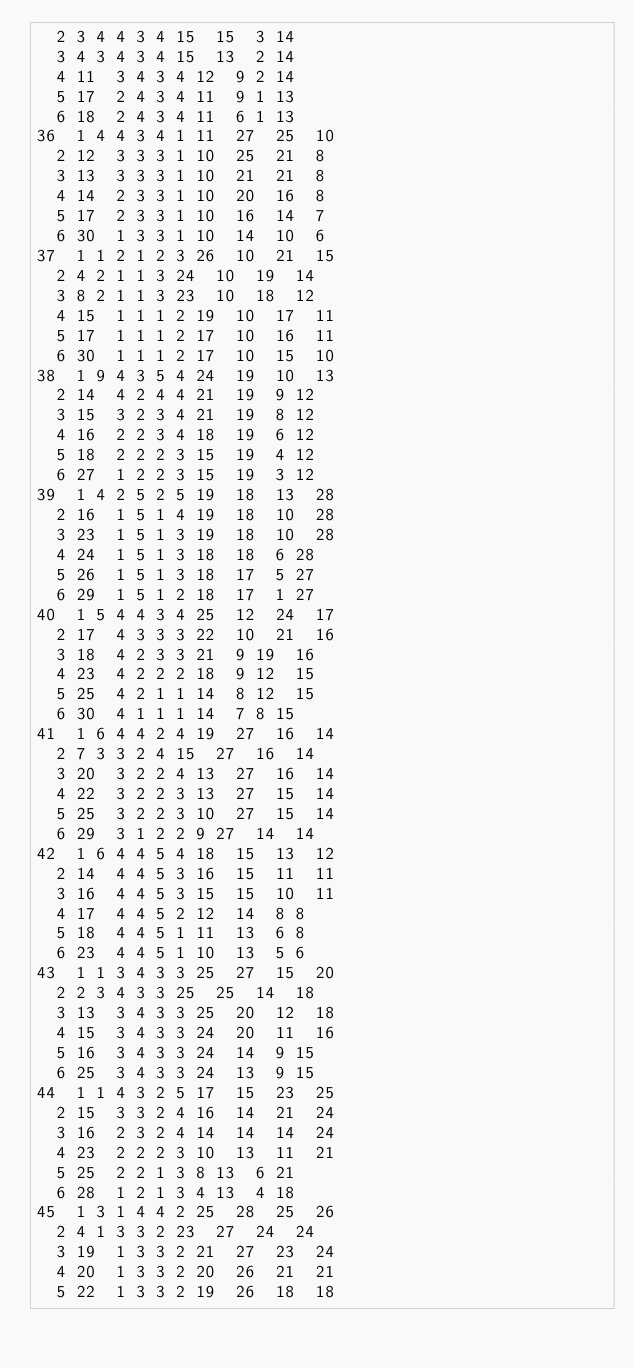Convert code to text. <code><loc_0><loc_0><loc_500><loc_500><_ObjectiveC_>	2	3	4	4	3	4	15	15	3	14	
	3	4	3	4	3	4	15	13	2	14	
	4	11	3	4	3	4	12	9	2	14	
	5	17	2	4	3	4	11	9	1	13	
	6	18	2	4	3	4	11	6	1	13	
36	1	4	4	3	4	1	11	27	25	10	
	2	12	3	3	3	1	10	25	21	8	
	3	13	3	3	3	1	10	21	21	8	
	4	14	2	3	3	1	10	20	16	8	
	5	17	2	3	3	1	10	16	14	7	
	6	30	1	3	3	1	10	14	10	6	
37	1	1	2	1	2	3	26	10	21	15	
	2	4	2	1	1	3	24	10	19	14	
	3	8	2	1	1	3	23	10	18	12	
	4	15	1	1	1	2	19	10	17	11	
	5	17	1	1	1	2	17	10	16	11	
	6	30	1	1	1	2	17	10	15	10	
38	1	9	4	3	5	4	24	19	10	13	
	2	14	4	2	4	4	21	19	9	12	
	3	15	3	2	3	4	21	19	8	12	
	4	16	2	2	3	4	18	19	6	12	
	5	18	2	2	2	3	15	19	4	12	
	6	27	1	2	2	3	15	19	3	12	
39	1	4	2	5	2	5	19	18	13	28	
	2	16	1	5	1	4	19	18	10	28	
	3	23	1	5	1	3	19	18	10	28	
	4	24	1	5	1	3	18	18	6	28	
	5	26	1	5	1	3	18	17	5	27	
	6	29	1	5	1	2	18	17	1	27	
40	1	5	4	4	3	4	25	12	24	17	
	2	17	4	3	3	3	22	10	21	16	
	3	18	4	2	3	3	21	9	19	16	
	4	23	4	2	2	2	18	9	12	15	
	5	25	4	2	1	1	14	8	12	15	
	6	30	4	1	1	1	14	7	8	15	
41	1	6	4	4	2	4	19	27	16	14	
	2	7	3	3	2	4	15	27	16	14	
	3	20	3	2	2	4	13	27	16	14	
	4	22	3	2	2	3	13	27	15	14	
	5	25	3	2	2	3	10	27	15	14	
	6	29	3	1	2	2	9	27	14	14	
42	1	6	4	4	5	4	18	15	13	12	
	2	14	4	4	5	3	16	15	11	11	
	3	16	4	4	5	3	15	15	10	11	
	4	17	4	4	5	2	12	14	8	8	
	5	18	4	4	5	1	11	13	6	8	
	6	23	4	4	5	1	10	13	5	6	
43	1	1	3	4	3	3	25	27	15	20	
	2	2	3	4	3	3	25	25	14	18	
	3	13	3	4	3	3	25	20	12	18	
	4	15	3	4	3	3	24	20	11	16	
	5	16	3	4	3	3	24	14	9	15	
	6	25	3	4	3	3	24	13	9	15	
44	1	1	4	3	2	5	17	15	23	25	
	2	15	3	3	2	4	16	14	21	24	
	3	16	2	3	2	4	14	14	14	24	
	4	23	2	2	2	3	10	13	11	21	
	5	25	2	2	1	3	8	13	6	21	
	6	28	1	2	1	3	4	13	4	18	
45	1	3	1	4	4	2	25	28	25	26	
	2	4	1	3	3	2	23	27	24	24	
	3	19	1	3	3	2	21	27	23	24	
	4	20	1	3	3	2	20	26	21	21	
	5	22	1	3	3	2	19	26	18	18	</code> 